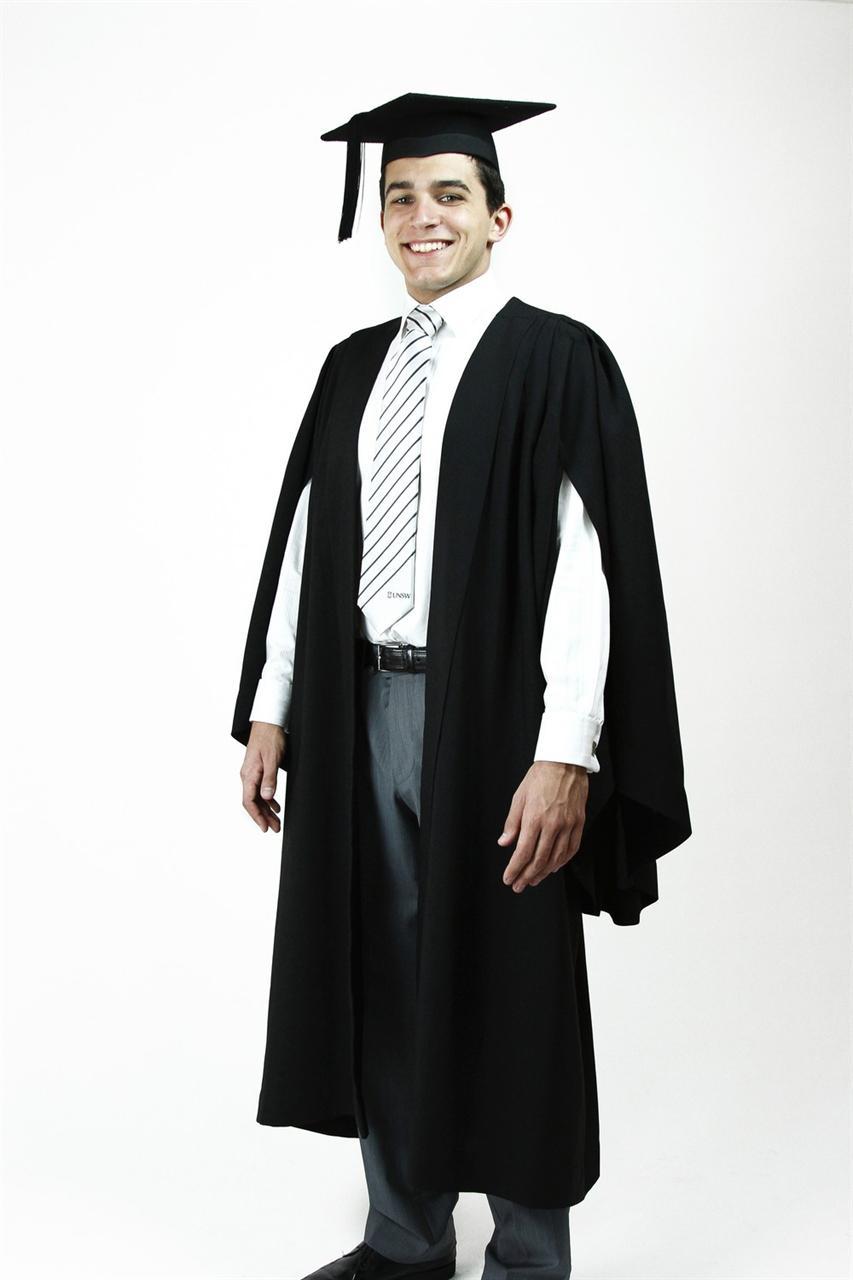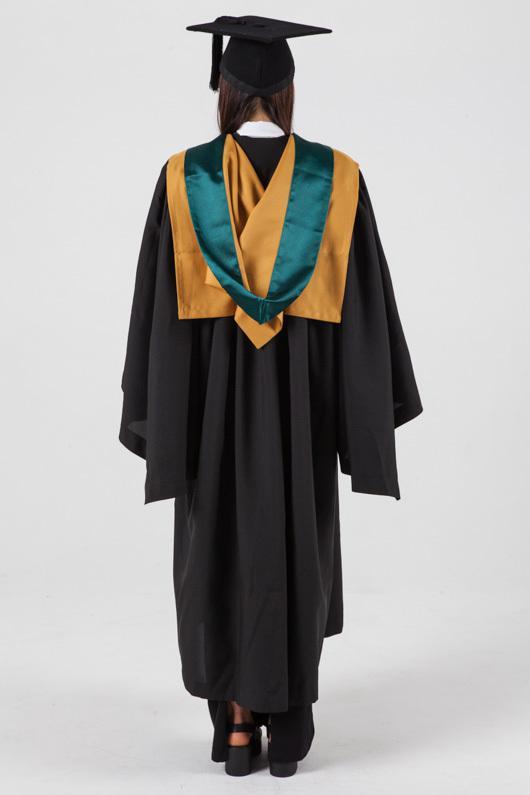The first image is the image on the left, the second image is the image on the right. For the images displayed, is the sentence "Exactly one camera-facing female and one camera-facing male are shown modeling graduation attire." factually correct? Answer yes or no. No. 